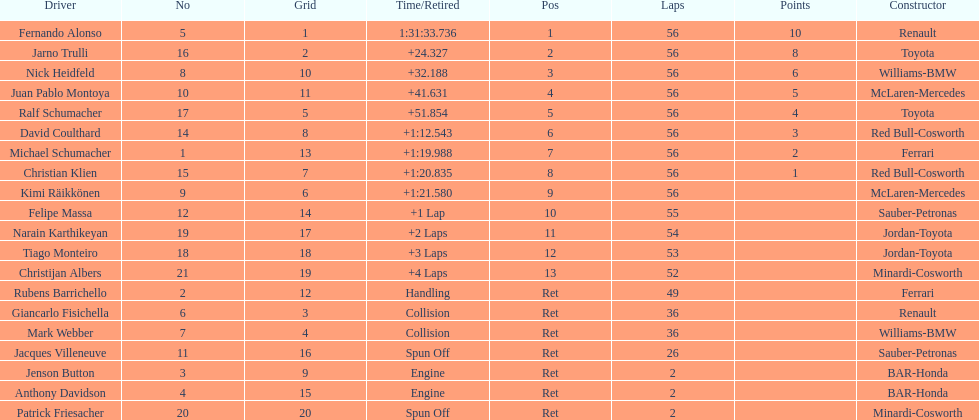How long did it take fernando alonso to finish the race? 1:31:33.736. 